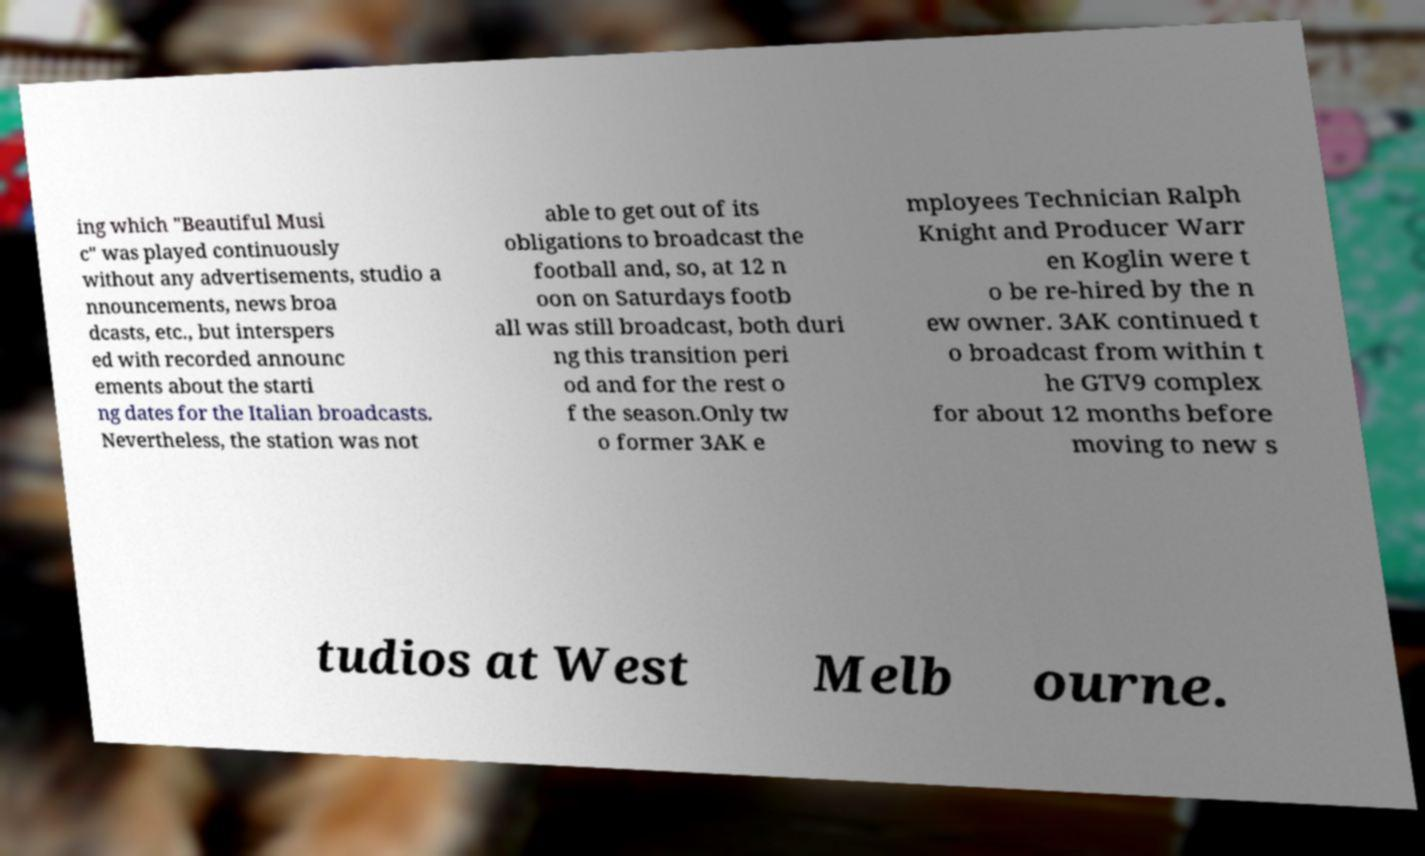Please identify and transcribe the text found in this image. ing which "Beautiful Musi c" was played continuously without any advertisements, studio a nnouncements, news broa dcasts, etc., but interspers ed with recorded announc ements about the starti ng dates for the Italian broadcasts. Nevertheless, the station was not able to get out of its obligations to broadcast the football and, so, at 12 n oon on Saturdays footb all was still broadcast, both duri ng this transition peri od and for the rest o f the season.Only tw o former 3AK e mployees Technician Ralph Knight and Producer Warr en Koglin were t o be re-hired by the n ew owner. 3AK continued t o broadcast from within t he GTV9 complex for about 12 months before moving to new s tudios at West Melb ourne. 